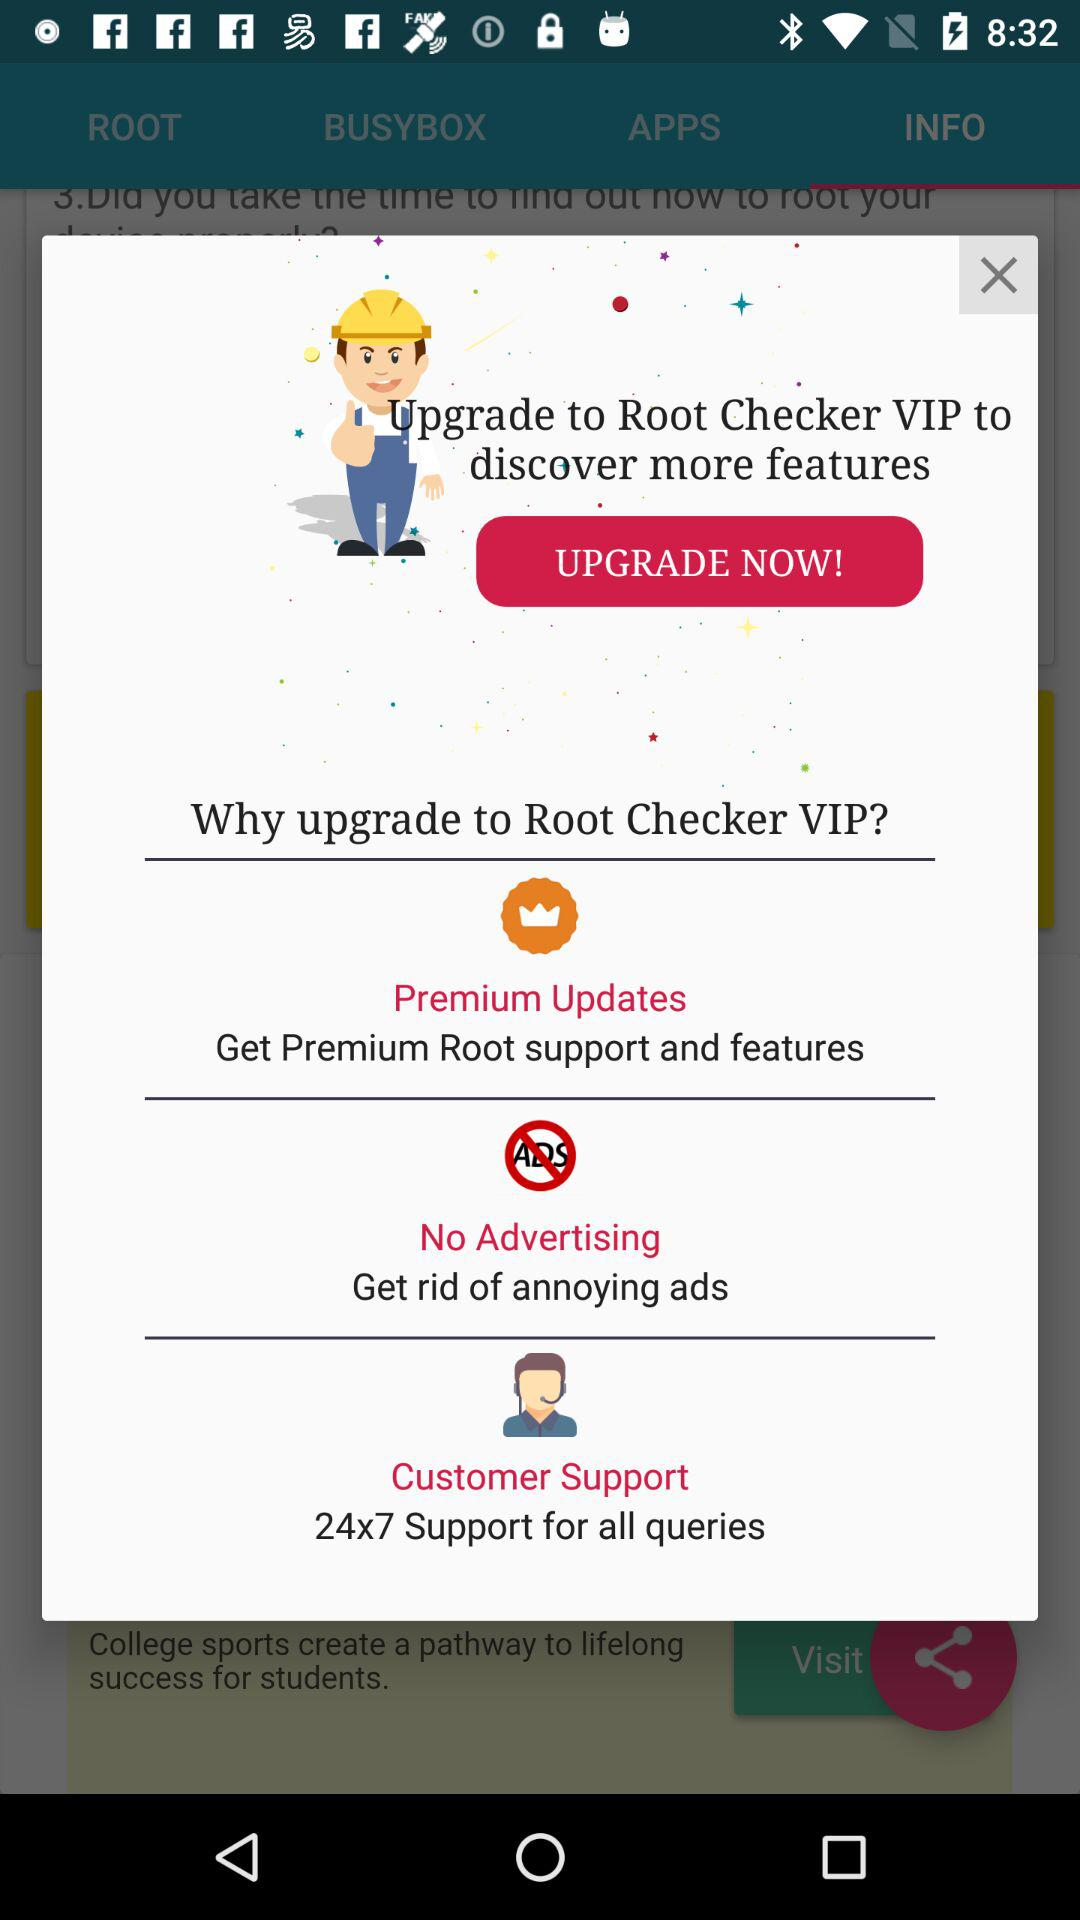What will you get if you upgrade to "Root Checker VIP"? You will get premium root support and features, get rid of annoying ads and 24x7 support for all queries. 